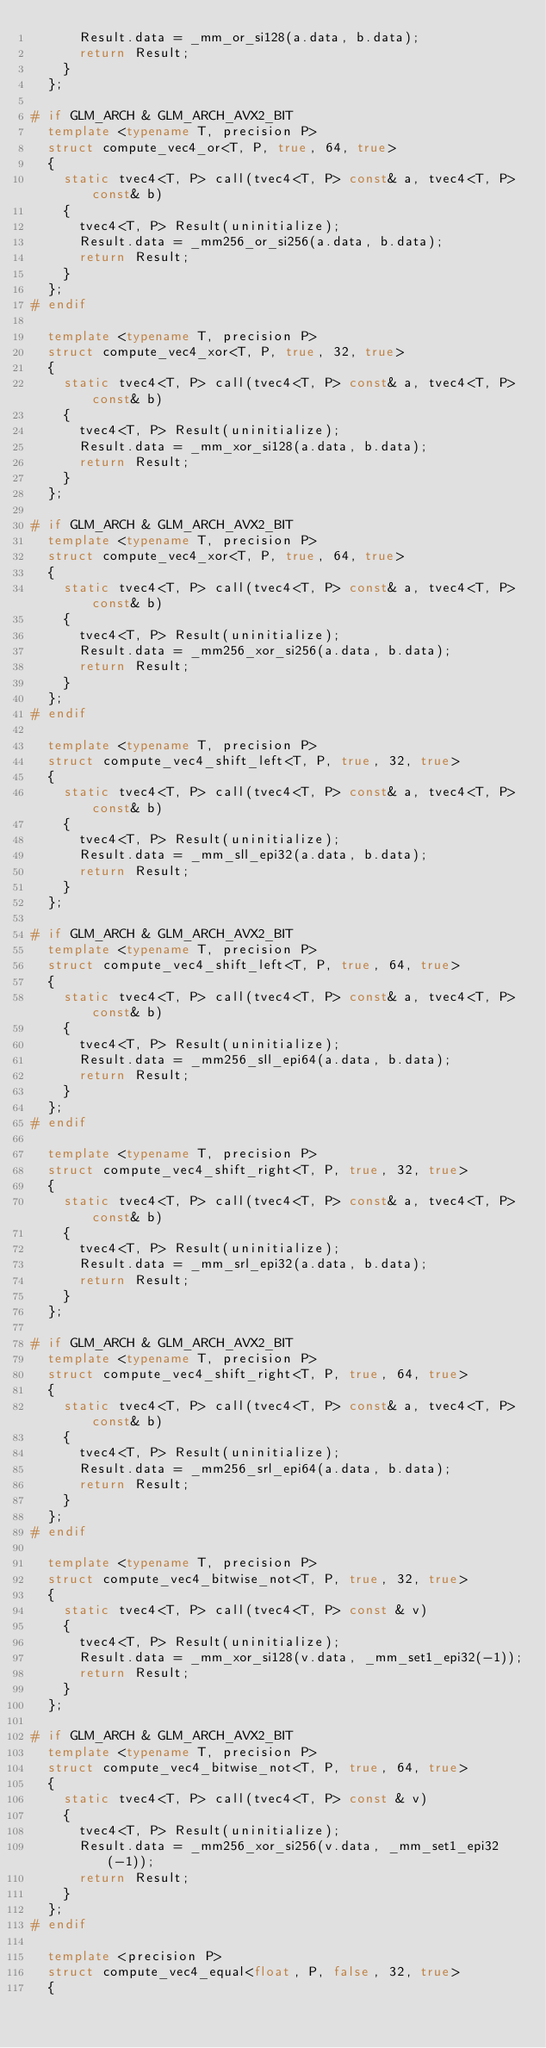<code> <loc_0><loc_0><loc_500><loc_500><_C++_>			Result.data = _mm_or_si128(a.data, b.data);
			return Result;
		}
	};

#	if GLM_ARCH & GLM_ARCH_AVX2_BIT
	template <typename T, precision P>
	struct compute_vec4_or<T, P, true, 64, true>
	{
		static tvec4<T, P> call(tvec4<T, P> const& a, tvec4<T, P> const& b)
		{
			tvec4<T, P> Result(uninitialize);
			Result.data = _mm256_or_si256(a.data, b.data);
			return Result;
		}
	};
#	endif

	template <typename T, precision P>
	struct compute_vec4_xor<T, P, true, 32, true>
	{
		static tvec4<T, P> call(tvec4<T, P> const& a, tvec4<T, P> const& b)
		{
			tvec4<T, P> Result(uninitialize);
			Result.data = _mm_xor_si128(a.data, b.data);
			return Result;
		}
	};

#	if GLM_ARCH & GLM_ARCH_AVX2_BIT
	template <typename T, precision P>
	struct compute_vec4_xor<T, P, true, 64, true>
	{
		static tvec4<T, P> call(tvec4<T, P> const& a, tvec4<T, P> const& b)
		{
			tvec4<T, P> Result(uninitialize);
			Result.data = _mm256_xor_si256(a.data, b.data);
			return Result;
		}
	};
#	endif

	template <typename T, precision P>
	struct compute_vec4_shift_left<T, P, true, 32, true>
	{
		static tvec4<T, P> call(tvec4<T, P> const& a, tvec4<T, P> const& b)
		{
			tvec4<T, P> Result(uninitialize);
			Result.data = _mm_sll_epi32(a.data, b.data);
			return Result;
		}
	};

#	if GLM_ARCH & GLM_ARCH_AVX2_BIT
	template <typename T, precision P>
	struct compute_vec4_shift_left<T, P, true, 64, true>
	{
		static tvec4<T, P> call(tvec4<T, P> const& a, tvec4<T, P> const& b)
		{
			tvec4<T, P> Result(uninitialize);
			Result.data = _mm256_sll_epi64(a.data, b.data);
			return Result;
		}
	};
#	endif

	template <typename T, precision P>
	struct compute_vec4_shift_right<T, P, true, 32, true>
	{
		static tvec4<T, P> call(tvec4<T, P> const& a, tvec4<T, P> const& b)
		{
			tvec4<T, P> Result(uninitialize);
			Result.data = _mm_srl_epi32(a.data, b.data);
			return Result;
		}
	};

#	if GLM_ARCH & GLM_ARCH_AVX2_BIT
	template <typename T, precision P>
	struct compute_vec4_shift_right<T, P, true, 64, true>
	{
		static tvec4<T, P> call(tvec4<T, P> const& a, tvec4<T, P> const& b)
		{
			tvec4<T, P> Result(uninitialize);
			Result.data = _mm256_srl_epi64(a.data, b.data);
			return Result;
		}
	};
#	endif

	template <typename T, precision P>
	struct compute_vec4_bitwise_not<T, P, true, 32, true>
	{
		static tvec4<T, P> call(tvec4<T, P> const & v)
		{
			tvec4<T, P> Result(uninitialize);
			Result.data = _mm_xor_si128(v.data, _mm_set1_epi32(-1));
			return Result;
		}
	};

#	if GLM_ARCH & GLM_ARCH_AVX2_BIT
	template <typename T, precision P>
	struct compute_vec4_bitwise_not<T, P, true, 64, true>
	{
		static tvec4<T, P> call(tvec4<T, P> const & v)
		{
			tvec4<T, P> Result(uninitialize);
			Result.data = _mm256_xor_si256(v.data, _mm_set1_epi32(-1));
			return Result;
		}
	};
#	endif

	template <precision P>
	struct compute_vec4_equal<float, P, false, 32, true>
	{</code> 